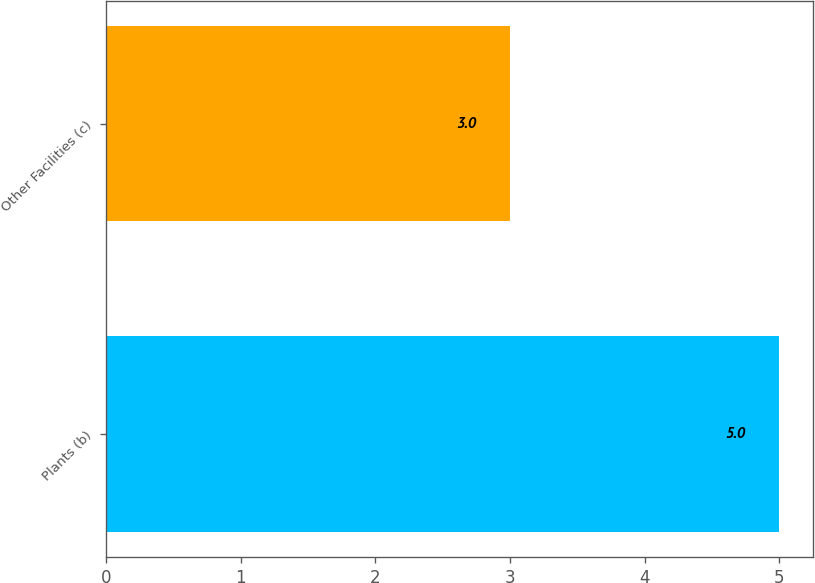Convert chart to OTSL. <chart><loc_0><loc_0><loc_500><loc_500><bar_chart><fcel>Plants (b)<fcel>Other Facilities (c)<nl><fcel>5<fcel>3<nl></chart> 